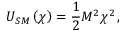<formula> <loc_0><loc_0><loc_500><loc_500>U _ { S M } \left ( \chi \right ) = \frac { 1 } { 2 } M ^ { 2 } \chi ^ { 2 } \, ,</formula> 